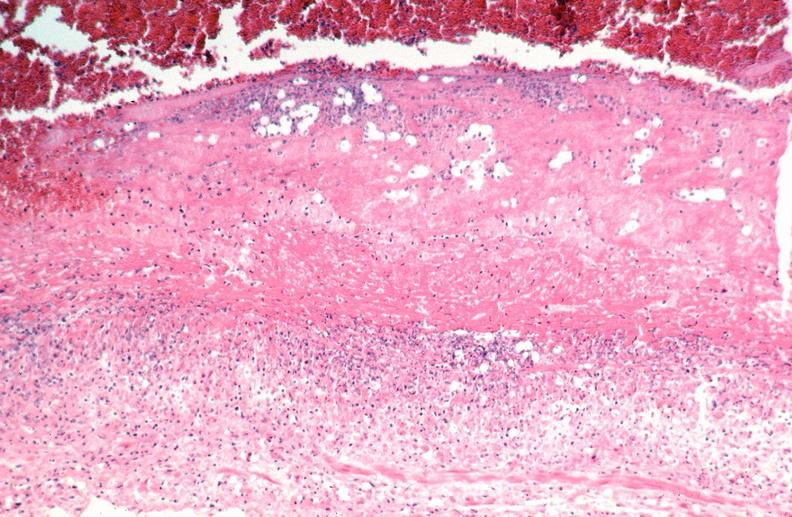what is present?
Answer the question using a single word or phrase. Cardiovascular 